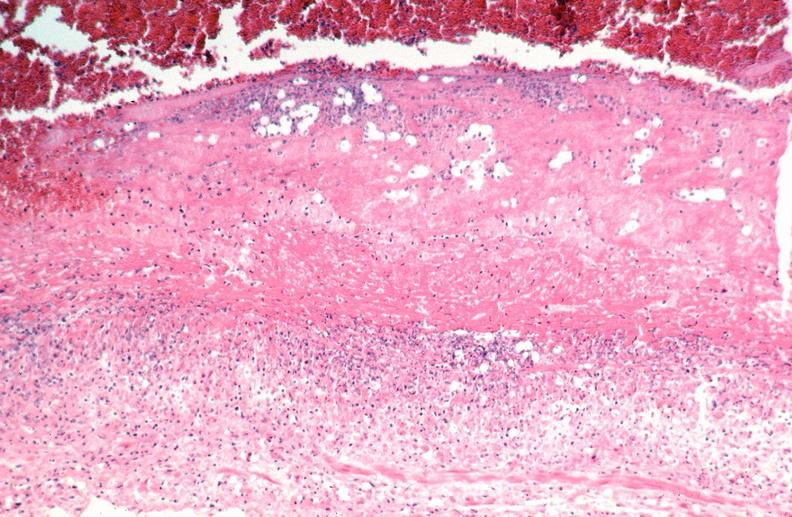what is present?
Answer the question using a single word or phrase. Cardiovascular 